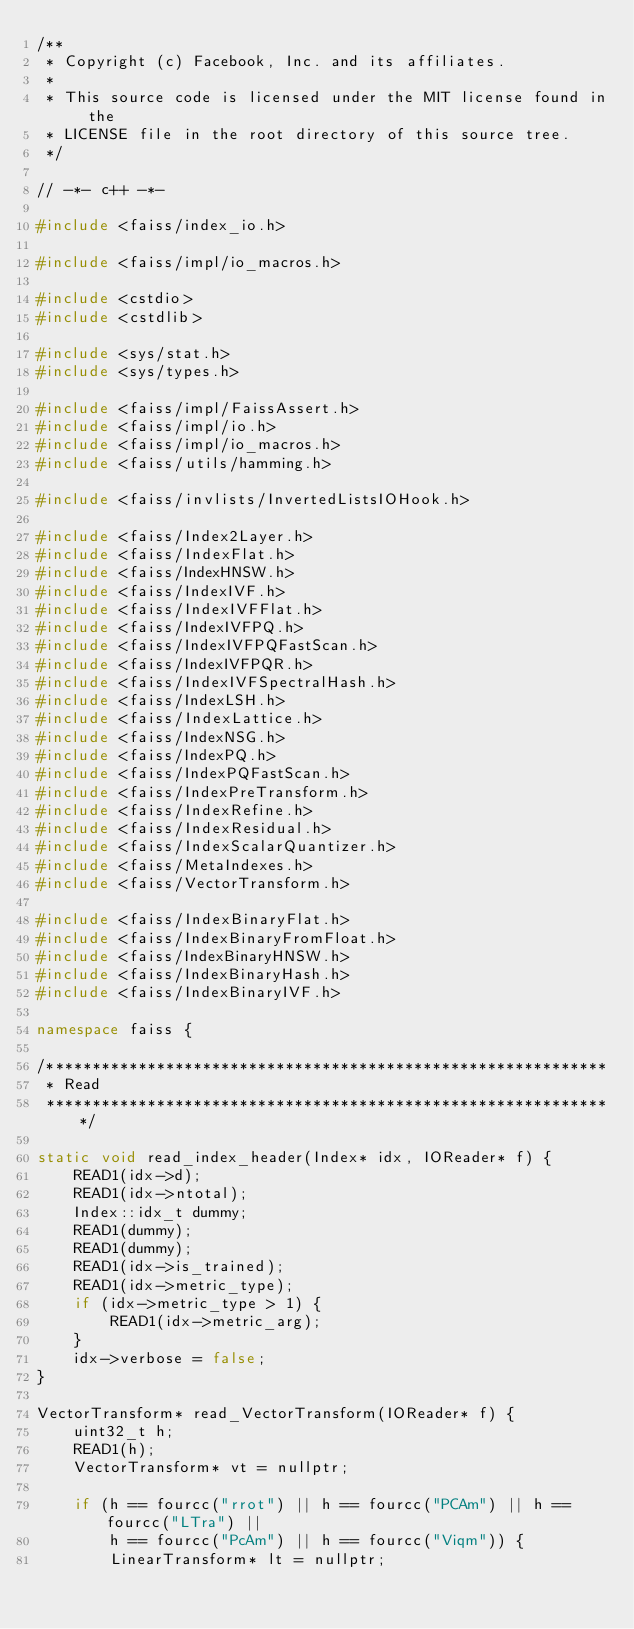Convert code to text. <code><loc_0><loc_0><loc_500><loc_500><_C++_>/**
 * Copyright (c) Facebook, Inc. and its affiliates.
 *
 * This source code is licensed under the MIT license found in the
 * LICENSE file in the root directory of this source tree.
 */

// -*- c++ -*-

#include <faiss/index_io.h>

#include <faiss/impl/io_macros.h>

#include <cstdio>
#include <cstdlib>

#include <sys/stat.h>
#include <sys/types.h>

#include <faiss/impl/FaissAssert.h>
#include <faiss/impl/io.h>
#include <faiss/impl/io_macros.h>
#include <faiss/utils/hamming.h>

#include <faiss/invlists/InvertedListsIOHook.h>

#include <faiss/Index2Layer.h>
#include <faiss/IndexFlat.h>
#include <faiss/IndexHNSW.h>
#include <faiss/IndexIVF.h>
#include <faiss/IndexIVFFlat.h>
#include <faiss/IndexIVFPQ.h>
#include <faiss/IndexIVFPQFastScan.h>
#include <faiss/IndexIVFPQR.h>
#include <faiss/IndexIVFSpectralHash.h>
#include <faiss/IndexLSH.h>
#include <faiss/IndexLattice.h>
#include <faiss/IndexNSG.h>
#include <faiss/IndexPQ.h>
#include <faiss/IndexPQFastScan.h>
#include <faiss/IndexPreTransform.h>
#include <faiss/IndexRefine.h>
#include <faiss/IndexResidual.h>
#include <faiss/IndexScalarQuantizer.h>
#include <faiss/MetaIndexes.h>
#include <faiss/VectorTransform.h>

#include <faiss/IndexBinaryFlat.h>
#include <faiss/IndexBinaryFromFloat.h>
#include <faiss/IndexBinaryHNSW.h>
#include <faiss/IndexBinaryHash.h>
#include <faiss/IndexBinaryIVF.h>

namespace faiss {

/*************************************************************
 * Read
 **************************************************************/

static void read_index_header(Index* idx, IOReader* f) {
    READ1(idx->d);
    READ1(idx->ntotal);
    Index::idx_t dummy;
    READ1(dummy);
    READ1(dummy);
    READ1(idx->is_trained);
    READ1(idx->metric_type);
    if (idx->metric_type > 1) {
        READ1(idx->metric_arg);
    }
    idx->verbose = false;
}

VectorTransform* read_VectorTransform(IOReader* f) {
    uint32_t h;
    READ1(h);
    VectorTransform* vt = nullptr;

    if (h == fourcc("rrot") || h == fourcc("PCAm") || h == fourcc("LTra") ||
        h == fourcc("PcAm") || h == fourcc("Viqm")) {
        LinearTransform* lt = nullptr;</code> 